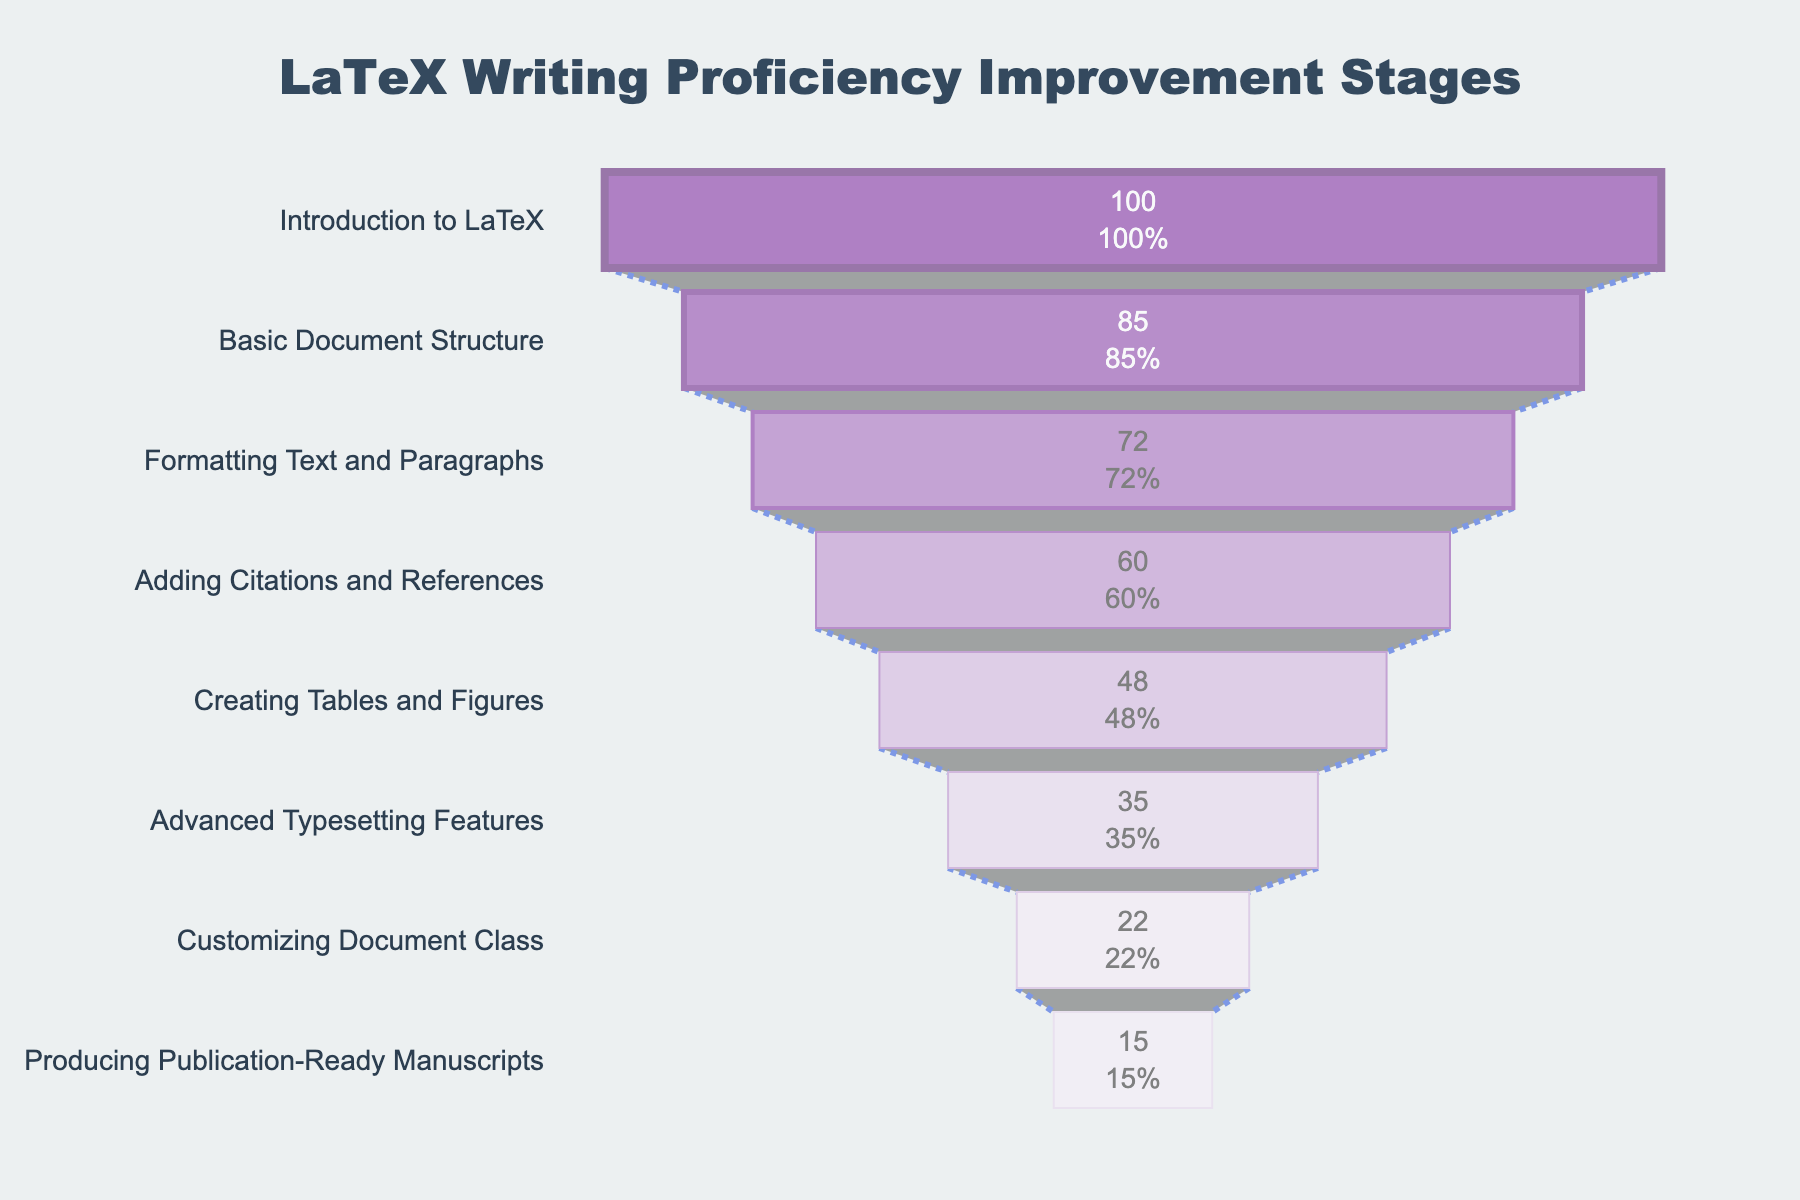What is the title of the funnel chart? The title is displayed at the top center of the funnel chart. It reads "LaTeX Writing Proficiency Improvement Stages".
Answer: LaTeX Writing Proficiency Improvement Stages How many stages are displayed in the funnel chart? The chart shows different stages, each labeled on the vertical axis. There are 8 stages in total.
Answer: 8 What is the stage with the highest number of students? By looking at the top of the funnel chart, the stage with the highest number of students is "Introduction to LaTeX" with 100 students.
Answer: Introduction to LaTeX What is the percentage of students who moved from "Formatting Text and Paragraphs" to "Adding Citations and References"? "Formatting Text and Paragraphs" has 72 students, and "Adding Citations and References" has 60 students. The percentage is (60/72) * 100 = 83.33%.
Answer: 83.33% How many more students are at the "Introduction to LaTeX" stage compared to the "Basic Document Structure" stage? There are 100 students at "Introduction to LaTeX" and 85 at "Basic Document Structure". The difference is 100 - 85 = 15 students.
Answer: 15 What is the approximate percentage loss of students from the stage "Creating Tables and Figures" to "Advanced Typesetting Features"? "Creating Tables and Figures" has 48 students, and "Advanced Typesetting Features" has 35 students. The percentage loss is ((48 - 35) / 48) * 100 = 27.08%.
Answer: 27.08% Which stage shows a significant drop in the number of students compared to its previous stage? By observing the funnel chart, the stage "Advanced Typesetting Features" (35 students) shows a significant drop from "Creating Tables and Figures" (48 students), a difference of 13 students.
Answer: Advanced Typesetting Features Compare the number of students at the "Customizing Document Class" stage to those at the "Producing Publication-Ready Manuscripts" stage. How many fewer students are there at the latter stage? "Customizing Document Class" has 22 students, and "Producing Publication-Ready Manuscripts" has 15 students. The difference is 22 - 15 = 7 students.
Answer: 7 Is the trend of student numbers increasing or decreasing as the stages progress? Observing the funnel chart from top to bottom, the number of students consistently decreases at each subsequent stage.
Answer: Decreasing What is the general trend in the proportions of students who advance to the next stage? Overall, the proportions of students advancing to the next stage decrease as the stages progress, indicating a gradual drop-off in participants at each subsequent proficiency stage.
Answer: Decreasing 